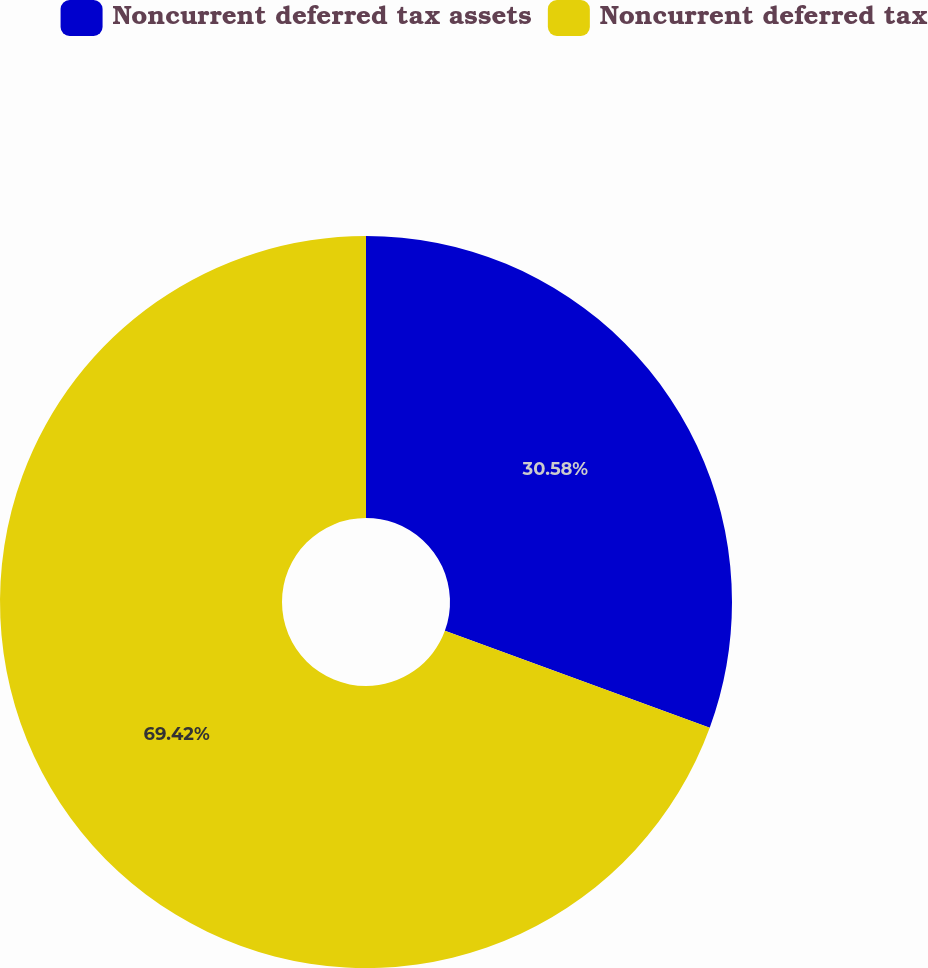Convert chart to OTSL. <chart><loc_0><loc_0><loc_500><loc_500><pie_chart><fcel>Noncurrent deferred tax assets<fcel>Noncurrent deferred tax<nl><fcel>30.58%<fcel>69.42%<nl></chart> 